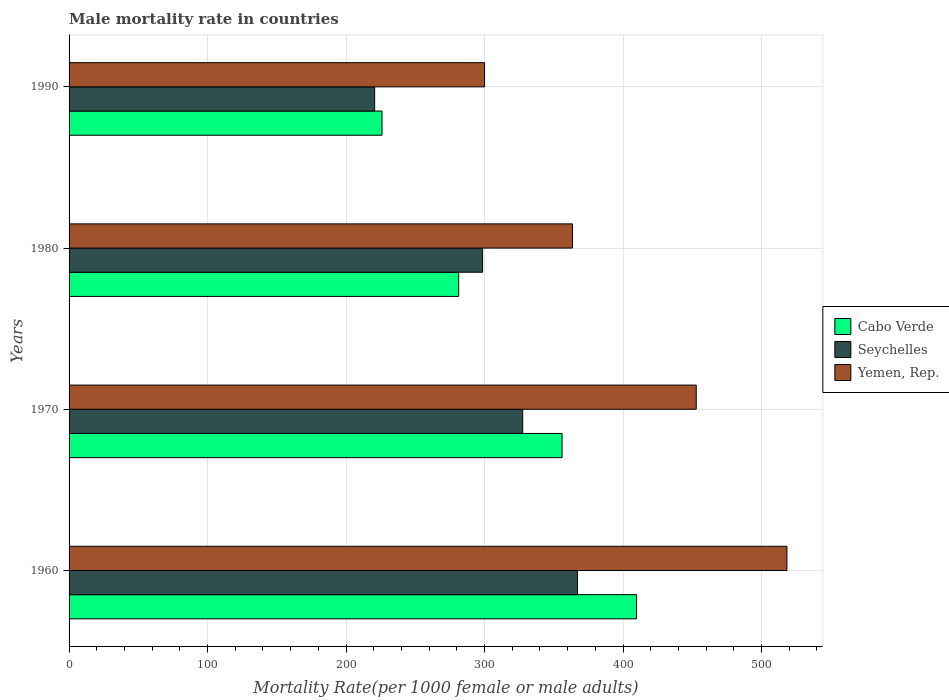How many different coloured bars are there?
Offer a very short reply. 3. Are the number of bars per tick equal to the number of legend labels?
Keep it short and to the point. Yes. In how many cases, is the number of bars for a given year not equal to the number of legend labels?
Make the answer very short. 0. What is the male mortality rate in Seychelles in 1970?
Your response must be concise. 327.56. Across all years, what is the maximum male mortality rate in Yemen, Rep.?
Keep it short and to the point. 518.34. Across all years, what is the minimum male mortality rate in Cabo Verde?
Keep it short and to the point. 225.97. In which year was the male mortality rate in Cabo Verde minimum?
Provide a succinct answer. 1990. What is the total male mortality rate in Seychelles in the graph?
Provide a succinct answer. 1213.89. What is the difference between the male mortality rate in Yemen, Rep. in 1970 and that in 1990?
Provide a short and direct response. 152.82. What is the difference between the male mortality rate in Cabo Verde in 1990 and the male mortality rate in Seychelles in 1980?
Offer a very short reply. -72.61. What is the average male mortality rate in Cabo Verde per year?
Your response must be concise. 318.26. In the year 1960, what is the difference between the male mortality rate in Cabo Verde and male mortality rate in Seychelles?
Keep it short and to the point. 42.67. In how many years, is the male mortality rate in Cabo Verde greater than 480 ?
Offer a very short reply. 0. What is the ratio of the male mortality rate in Seychelles in 1970 to that in 1980?
Provide a short and direct response. 1.1. Is the male mortality rate in Seychelles in 1970 less than that in 1990?
Your answer should be very brief. No. What is the difference between the highest and the second highest male mortality rate in Yemen, Rep.?
Offer a terse response. 65.5. What is the difference between the highest and the lowest male mortality rate in Seychelles?
Offer a very short reply. 146.47. In how many years, is the male mortality rate in Seychelles greater than the average male mortality rate in Seychelles taken over all years?
Provide a short and direct response. 2. What does the 2nd bar from the top in 1970 represents?
Provide a succinct answer. Seychelles. What does the 2nd bar from the bottom in 1960 represents?
Your answer should be very brief. Seychelles. How many years are there in the graph?
Your response must be concise. 4. What is the difference between two consecutive major ticks on the X-axis?
Provide a short and direct response. 100. Are the values on the major ticks of X-axis written in scientific E-notation?
Ensure brevity in your answer.  No. Does the graph contain any zero values?
Offer a terse response. No. Where does the legend appear in the graph?
Keep it short and to the point. Center right. How many legend labels are there?
Provide a short and direct response. 3. How are the legend labels stacked?
Keep it short and to the point. Vertical. What is the title of the graph?
Give a very brief answer. Male mortality rate in countries. Does "Colombia" appear as one of the legend labels in the graph?
Your answer should be very brief. No. What is the label or title of the X-axis?
Give a very brief answer. Mortality Rate(per 1000 female or male adults). What is the label or title of the Y-axis?
Provide a succinct answer. Years. What is the Mortality Rate(per 1000 female or male adults) in Cabo Verde in 1960?
Make the answer very short. 409.79. What is the Mortality Rate(per 1000 female or male adults) in Seychelles in 1960?
Make the answer very short. 367.11. What is the Mortality Rate(per 1000 female or male adults) of Yemen, Rep. in 1960?
Provide a succinct answer. 518.34. What is the Mortality Rate(per 1000 female or male adults) in Cabo Verde in 1970?
Your answer should be compact. 355.96. What is the Mortality Rate(per 1000 female or male adults) of Seychelles in 1970?
Your answer should be compact. 327.56. What is the Mortality Rate(per 1000 female or male adults) in Yemen, Rep. in 1970?
Your response must be concise. 452.84. What is the Mortality Rate(per 1000 female or male adults) in Cabo Verde in 1980?
Provide a short and direct response. 281.32. What is the Mortality Rate(per 1000 female or male adults) of Seychelles in 1980?
Keep it short and to the point. 298.57. What is the Mortality Rate(per 1000 female or male adults) in Yemen, Rep. in 1980?
Provide a succinct answer. 363.53. What is the Mortality Rate(per 1000 female or male adults) of Cabo Verde in 1990?
Make the answer very short. 225.97. What is the Mortality Rate(per 1000 female or male adults) of Seychelles in 1990?
Your answer should be compact. 220.65. What is the Mortality Rate(per 1000 female or male adults) in Yemen, Rep. in 1990?
Offer a very short reply. 300.02. Across all years, what is the maximum Mortality Rate(per 1000 female or male adults) in Cabo Verde?
Your answer should be very brief. 409.79. Across all years, what is the maximum Mortality Rate(per 1000 female or male adults) in Seychelles?
Ensure brevity in your answer.  367.11. Across all years, what is the maximum Mortality Rate(per 1000 female or male adults) of Yemen, Rep.?
Your answer should be compact. 518.34. Across all years, what is the minimum Mortality Rate(per 1000 female or male adults) of Cabo Verde?
Provide a succinct answer. 225.97. Across all years, what is the minimum Mortality Rate(per 1000 female or male adults) in Seychelles?
Ensure brevity in your answer.  220.65. Across all years, what is the minimum Mortality Rate(per 1000 female or male adults) of Yemen, Rep.?
Your answer should be compact. 300.02. What is the total Mortality Rate(per 1000 female or male adults) of Cabo Verde in the graph?
Your response must be concise. 1273.03. What is the total Mortality Rate(per 1000 female or male adults) in Seychelles in the graph?
Offer a very short reply. 1213.89. What is the total Mortality Rate(per 1000 female or male adults) of Yemen, Rep. in the graph?
Provide a short and direct response. 1634.73. What is the difference between the Mortality Rate(per 1000 female or male adults) of Cabo Verde in 1960 and that in 1970?
Ensure brevity in your answer.  53.83. What is the difference between the Mortality Rate(per 1000 female or male adults) of Seychelles in 1960 and that in 1970?
Keep it short and to the point. 39.55. What is the difference between the Mortality Rate(per 1000 female or male adults) in Yemen, Rep. in 1960 and that in 1970?
Your answer should be very brief. 65.5. What is the difference between the Mortality Rate(per 1000 female or male adults) of Cabo Verde in 1960 and that in 1980?
Provide a succinct answer. 128.47. What is the difference between the Mortality Rate(per 1000 female or male adults) of Seychelles in 1960 and that in 1980?
Ensure brevity in your answer.  68.54. What is the difference between the Mortality Rate(per 1000 female or male adults) in Yemen, Rep. in 1960 and that in 1980?
Ensure brevity in your answer.  154.81. What is the difference between the Mortality Rate(per 1000 female or male adults) in Cabo Verde in 1960 and that in 1990?
Ensure brevity in your answer.  183.82. What is the difference between the Mortality Rate(per 1000 female or male adults) of Seychelles in 1960 and that in 1990?
Keep it short and to the point. 146.47. What is the difference between the Mortality Rate(per 1000 female or male adults) in Yemen, Rep. in 1960 and that in 1990?
Ensure brevity in your answer.  218.32. What is the difference between the Mortality Rate(per 1000 female or male adults) in Cabo Verde in 1970 and that in 1980?
Keep it short and to the point. 74.64. What is the difference between the Mortality Rate(per 1000 female or male adults) of Seychelles in 1970 and that in 1980?
Provide a short and direct response. 28.99. What is the difference between the Mortality Rate(per 1000 female or male adults) of Yemen, Rep. in 1970 and that in 1980?
Your answer should be compact. 89.31. What is the difference between the Mortality Rate(per 1000 female or male adults) in Cabo Verde in 1970 and that in 1990?
Keep it short and to the point. 130. What is the difference between the Mortality Rate(per 1000 female or male adults) of Seychelles in 1970 and that in 1990?
Keep it short and to the point. 106.92. What is the difference between the Mortality Rate(per 1000 female or male adults) of Yemen, Rep. in 1970 and that in 1990?
Provide a short and direct response. 152.82. What is the difference between the Mortality Rate(per 1000 female or male adults) of Cabo Verde in 1980 and that in 1990?
Offer a very short reply. 55.35. What is the difference between the Mortality Rate(per 1000 female or male adults) in Seychelles in 1980 and that in 1990?
Provide a succinct answer. 77.93. What is the difference between the Mortality Rate(per 1000 female or male adults) in Yemen, Rep. in 1980 and that in 1990?
Your answer should be compact. 63.51. What is the difference between the Mortality Rate(per 1000 female or male adults) in Cabo Verde in 1960 and the Mortality Rate(per 1000 female or male adults) in Seychelles in 1970?
Provide a short and direct response. 82.23. What is the difference between the Mortality Rate(per 1000 female or male adults) of Cabo Verde in 1960 and the Mortality Rate(per 1000 female or male adults) of Yemen, Rep. in 1970?
Keep it short and to the point. -43.05. What is the difference between the Mortality Rate(per 1000 female or male adults) in Seychelles in 1960 and the Mortality Rate(per 1000 female or male adults) in Yemen, Rep. in 1970?
Your answer should be compact. -85.73. What is the difference between the Mortality Rate(per 1000 female or male adults) of Cabo Verde in 1960 and the Mortality Rate(per 1000 female or male adults) of Seychelles in 1980?
Offer a terse response. 111.21. What is the difference between the Mortality Rate(per 1000 female or male adults) in Cabo Verde in 1960 and the Mortality Rate(per 1000 female or male adults) in Yemen, Rep. in 1980?
Give a very brief answer. 46.26. What is the difference between the Mortality Rate(per 1000 female or male adults) of Seychelles in 1960 and the Mortality Rate(per 1000 female or male adults) of Yemen, Rep. in 1980?
Your answer should be very brief. 3.58. What is the difference between the Mortality Rate(per 1000 female or male adults) of Cabo Verde in 1960 and the Mortality Rate(per 1000 female or male adults) of Seychelles in 1990?
Your answer should be very brief. 189.14. What is the difference between the Mortality Rate(per 1000 female or male adults) in Cabo Verde in 1960 and the Mortality Rate(per 1000 female or male adults) in Yemen, Rep. in 1990?
Your response must be concise. 109.77. What is the difference between the Mortality Rate(per 1000 female or male adults) of Seychelles in 1960 and the Mortality Rate(per 1000 female or male adults) of Yemen, Rep. in 1990?
Offer a very short reply. 67.09. What is the difference between the Mortality Rate(per 1000 female or male adults) of Cabo Verde in 1970 and the Mortality Rate(per 1000 female or male adults) of Seychelles in 1980?
Provide a short and direct response. 57.39. What is the difference between the Mortality Rate(per 1000 female or male adults) in Cabo Verde in 1970 and the Mortality Rate(per 1000 female or male adults) in Yemen, Rep. in 1980?
Provide a succinct answer. -7.57. What is the difference between the Mortality Rate(per 1000 female or male adults) of Seychelles in 1970 and the Mortality Rate(per 1000 female or male adults) of Yemen, Rep. in 1980?
Keep it short and to the point. -35.97. What is the difference between the Mortality Rate(per 1000 female or male adults) of Cabo Verde in 1970 and the Mortality Rate(per 1000 female or male adults) of Seychelles in 1990?
Your answer should be compact. 135.32. What is the difference between the Mortality Rate(per 1000 female or male adults) in Cabo Verde in 1970 and the Mortality Rate(per 1000 female or male adults) in Yemen, Rep. in 1990?
Keep it short and to the point. 55.94. What is the difference between the Mortality Rate(per 1000 female or male adults) in Seychelles in 1970 and the Mortality Rate(per 1000 female or male adults) in Yemen, Rep. in 1990?
Provide a succinct answer. 27.54. What is the difference between the Mortality Rate(per 1000 female or male adults) in Cabo Verde in 1980 and the Mortality Rate(per 1000 female or male adults) in Seychelles in 1990?
Make the answer very short. 60.67. What is the difference between the Mortality Rate(per 1000 female or male adults) in Cabo Verde in 1980 and the Mortality Rate(per 1000 female or male adults) in Yemen, Rep. in 1990?
Provide a succinct answer. -18.7. What is the difference between the Mortality Rate(per 1000 female or male adults) of Seychelles in 1980 and the Mortality Rate(per 1000 female or male adults) of Yemen, Rep. in 1990?
Make the answer very short. -1.44. What is the average Mortality Rate(per 1000 female or male adults) in Cabo Verde per year?
Your answer should be very brief. 318.26. What is the average Mortality Rate(per 1000 female or male adults) of Seychelles per year?
Your response must be concise. 303.47. What is the average Mortality Rate(per 1000 female or male adults) of Yemen, Rep. per year?
Ensure brevity in your answer.  408.68. In the year 1960, what is the difference between the Mortality Rate(per 1000 female or male adults) in Cabo Verde and Mortality Rate(per 1000 female or male adults) in Seychelles?
Give a very brief answer. 42.67. In the year 1960, what is the difference between the Mortality Rate(per 1000 female or male adults) in Cabo Verde and Mortality Rate(per 1000 female or male adults) in Yemen, Rep.?
Keep it short and to the point. -108.56. In the year 1960, what is the difference between the Mortality Rate(per 1000 female or male adults) of Seychelles and Mortality Rate(per 1000 female or male adults) of Yemen, Rep.?
Make the answer very short. -151.23. In the year 1970, what is the difference between the Mortality Rate(per 1000 female or male adults) in Cabo Verde and Mortality Rate(per 1000 female or male adults) in Seychelles?
Provide a short and direct response. 28.4. In the year 1970, what is the difference between the Mortality Rate(per 1000 female or male adults) of Cabo Verde and Mortality Rate(per 1000 female or male adults) of Yemen, Rep.?
Your answer should be very brief. -96.88. In the year 1970, what is the difference between the Mortality Rate(per 1000 female or male adults) in Seychelles and Mortality Rate(per 1000 female or male adults) in Yemen, Rep.?
Give a very brief answer. -125.28. In the year 1980, what is the difference between the Mortality Rate(per 1000 female or male adults) of Cabo Verde and Mortality Rate(per 1000 female or male adults) of Seychelles?
Your response must be concise. -17.26. In the year 1980, what is the difference between the Mortality Rate(per 1000 female or male adults) in Cabo Verde and Mortality Rate(per 1000 female or male adults) in Yemen, Rep.?
Provide a succinct answer. -82.21. In the year 1980, what is the difference between the Mortality Rate(per 1000 female or male adults) in Seychelles and Mortality Rate(per 1000 female or male adults) in Yemen, Rep.?
Keep it short and to the point. -64.96. In the year 1990, what is the difference between the Mortality Rate(per 1000 female or male adults) in Cabo Verde and Mortality Rate(per 1000 female or male adults) in Seychelles?
Offer a terse response. 5.32. In the year 1990, what is the difference between the Mortality Rate(per 1000 female or male adults) of Cabo Verde and Mortality Rate(per 1000 female or male adults) of Yemen, Rep.?
Your response must be concise. -74.05. In the year 1990, what is the difference between the Mortality Rate(per 1000 female or male adults) in Seychelles and Mortality Rate(per 1000 female or male adults) in Yemen, Rep.?
Your answer should be very brief. -79.37. What is the ratio of the Mortality Rate(per 1000 female or male adults) in Cabo Verde in 1960 to that in 1970?
Keep it short and to the point. 1.15. What is the ratio of the Mortality Rate(per 1000 female or male adults) of Seychelles in 1960 to that in 1970?
Offer a terse response. 1.12. What is the ratio of the Mortality Rate(per 1000 female or male adults) of Yemen, Rep. in 1960 to that in 1970?
Provide a succinct answer. 1.14. What is the ratio of the Mortality Rate(per 1000 female or male adults) of Cabo Verde in 1960 to that in 1980?
Your answer should be very brief. 1.46. What is the ratio of the Mortality Rate(per 1000 female or male adults) of Seychelles in 1960 to that in 1980?
Offer a very short reply. 1.23. What is the ratio of the Mortality Rate(per 1000 female or male adults) in Yemen, Rep. in 1960 to that in 1980?
Your answer should be compact. 1.43. What is the ratio of the Mortality Rate(per 1000 female or male adults) in Cabo Verde in 1960 to that in 1990?
Your response must be concise. 1.81. What is the ratio of the Mortality Rate(per 1000 female or male adults) of Seychelles in 1960 to that in 1990?
Offer a very short reply. 1.66. What is the ratio of the Mortality Rate(per 1000 female or male adults) in Yemen, Rep. in 1960 to that in 1990?
Make the answer very short. 1.73. What is the ratio of the Mortality Rate(per 1000 female or male adults) of Cabo Verde in 1970 to that in 1980?
Offer a very short reply. 1.27. What is the ratio of the Mortality Rate(per 1000 female or male adults) in Seychelles in 1970 to that in 1980?
Keep it short and to the point. 1.1. What is the ratio of the Mortality Rate(per 1000 female or male adults) of Yemen, Rep. in 1970 to that in 1980?
Give a very brief answer. 1.25. What is the ratio of the Mortality Rate(per 1000 female or male adults) in Cabo Verde in 1970 to that in 1990?
Your answer should be very brief. 1.58. What is the ratio of the Mortality Rate(per 1000 female or male adults) in Seychelles in 1970 to that in 1990?
Provide a short and direct response. 1.48. What is the ratio of the Mortality Rate(per 1000 female or male adults) of Yemen, Rep. in 1970 to that in 1990?
Your answer should be very brief. 1.51. What is the ratio of the Mortality Rate(per 1000 female or male adults) in Cabo Verde in 1980 to that in 1990?
Provide a succinct answer. 1.25. What is the ratio of the Mortality Rate(per 1000 female or male adults) in Seychelles in 1980 to that in 1990?
Your answer should be compact. 1.35. What is the ratio of the Mortality Rate(per 1000 female or male adults) in Yemen, Rep. in 1980 to that in 1990?
Your answer should be compact. 1.21. What is the difference between the highest and the second highest Mortality Rate(per 1000 female or male adults) of Cabo Verde?
Offer a terse response. 53.83. What is the difference between the highest and the second highest Mortality Rate(per 1000 female or male adults) in Seychelles?
Give a very brief answer. 39.55. What is the difference between the highest and the second highest Mortality Rate(per 1000 female or male adults) of Yemen, Rep.?
Give a very brief answer. 65.5. What is the difference between the highest and the lowest Mortality Rate(per 1000 female or male adults) in Cabo Verde?
Offer a very short reply. 183.82. What is the difference between the highest and the lowest Mortality Rate(per 1000 female or male adults) of Seychelles?
Keep it short and to the point. 146.47. What is the difference between the highest and the lowest Mortality Rate(per 1000 female or male adults) of Yemen, Rep.?
Ensure brevity in your answer.  218.32. 